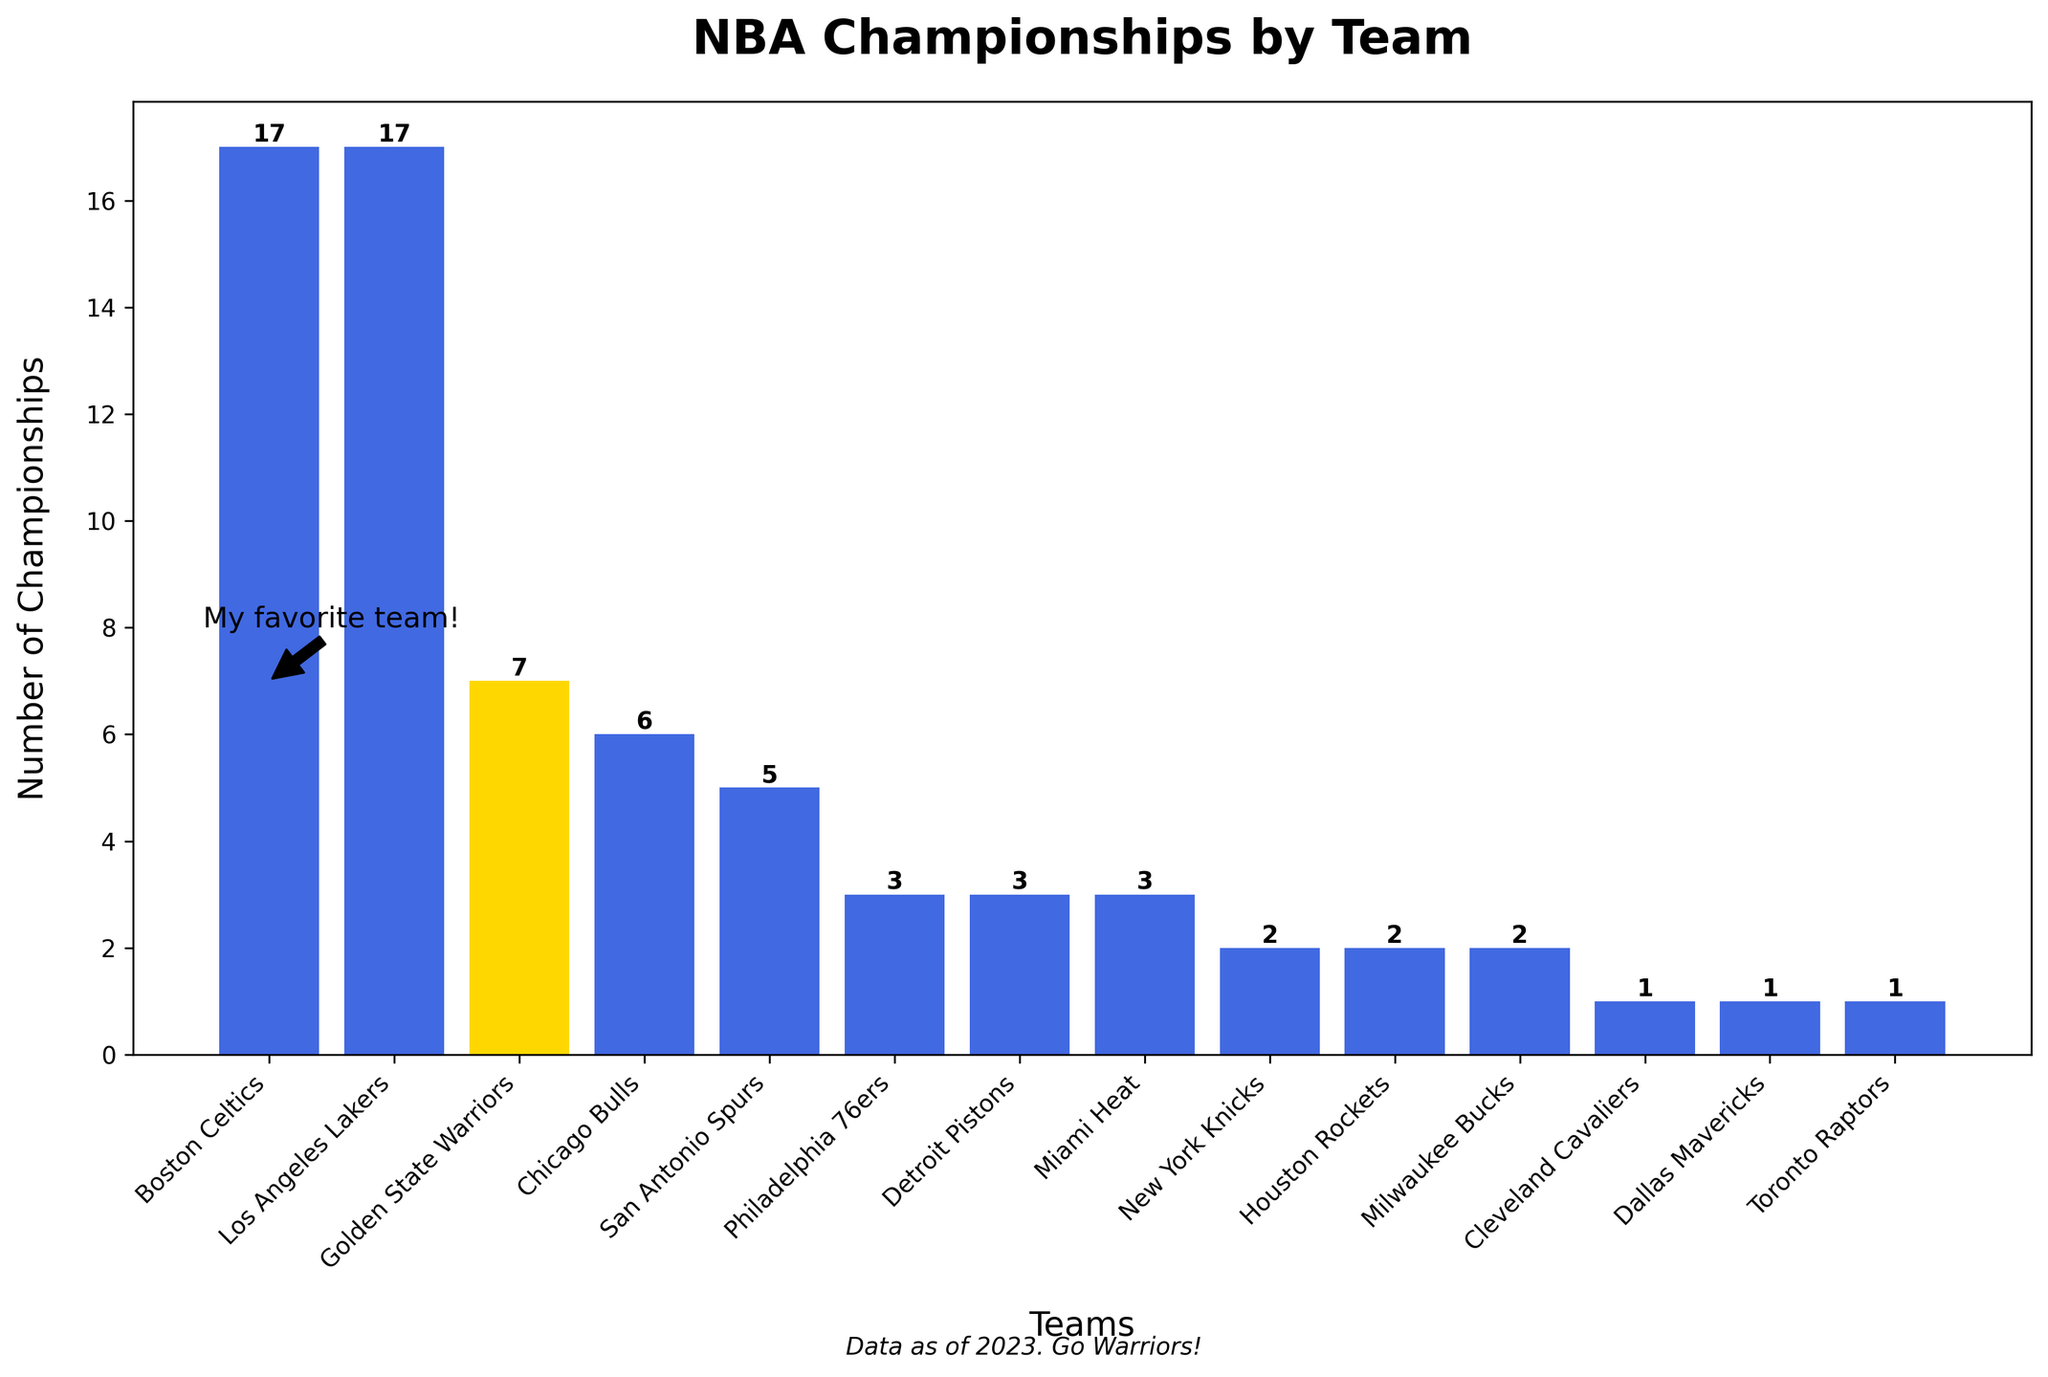Which team has the highest number of championships? The Boston Celtics and Los Angeles Lakers both have 17 championships, which is the highest number shown in the chart.
Answer: Boston Celtics and Los Angeles Lakers What is the total number of championships won by all teams combined? Add the number of championships for all the teams: 7 (Golden State Warriors) + 17 (Boston Celtics) + 17 (Los Angeles Lakers) + 6 (Chicago Bulls) + 5 (San Antonio Spurs) + 3 (Philadelphia 76ers) + 3 (Detroit Pistons) + 3 (Miami Heat) + 2 (New York Knicks) + 2 (Houston Rockets) + 2 (Milwaukee Bucks) + 1 (Cleveland Cavaliers) + 1 (Dallas Mavericks) + 1 (Toronto Raptors) = 70.
Answer: 70 How many more championships do the Golden State Warriors need to match the number of championships won by the Chicago Bulls? The Chicago Bulls have 6 championships, and the Golden State Warriors have 7. The Golden State Warriors already have 1 more championship than the Chicago Bulls.
Answer: 0 What are the colors of the bars representing the Golden State Warriors and the Los Angeles Lakers? The bar for the Golden State Warriors is colored gold, while the bar for the Los Angeles Lakers is colored royal blue.
Answer: Gold and royal blue Which teams have won exactly 3 championships each? The Philadelphia 76ers, Detroit Pistons, and Miami Heat have each won exactly 3 championships.
Answer: Philadelphia 76ers, Detroit Pistons, Miami Heat How many teams have won 2 championships each? Count the number of teams with 2 championships: The New York Knicks, Houston Rockets, and Milwaukee Bucks, which is a total of 3 teams.
Answer: 3 By how much do the total championships of the Boston Celtics and Los Angeles Lakers exceed that of the Golden State Warriors? The Boston Celtics and Los Angeles Lakers each have 17 championships, so combined they have 34 championships. The Golden State Warriors have 7 championships. The difference is 34 - 7 = 27.
Answer: 27 Which team has fewer championships: the Cleveland Cavaliers or the Dallas Mavericks? Both the Cleveland Cavaliers and the Dallas Mavericks have 1 championship each, so neither has fewer championships than the other.
Answer: Neither How does the height of the bar representing the Golden State Warriors compare to the height of the bar representing the San Antonio Spurs? The bar for the Golden State Warriors (7 championships) is taller than the bar for the San Antonio Spurs (5 championships).
Answer: Taller How many more championships do the Golden State Warriors need to reach 10 championships in total? The Golden State Warriors have 7 championships and need 3 more to reach a total of 10 championships (10 - 7 = 3).
Answer: 3 